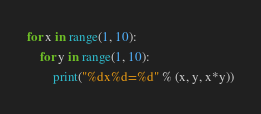Convert code to text. <code><loc_0><loc_0><loc_500><loc_500><_Python_>for x in range(1, 10):
    for y in range(1, 10):
        print("%dx%d=%d" % (x, y, x*y))

</code> 